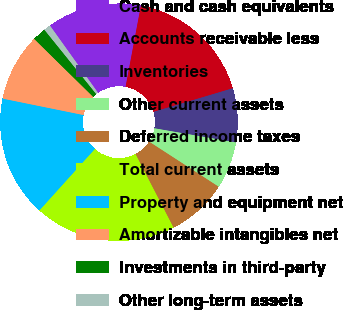<chart> <loc_0><loc_0><loc_500><loc_500><pie_chart><fcel>Cash and cash equivalents<fcel>Accounts receivable less<fcel>Inventories<fcel>Other current assets<fcel>Deferred income taxes<fcel>Total current assets<fcel>Property and equipment net<fcel>Amortizable intangibles net<fcel>Investments in third-party<fcel>Other long-term assets<nl><fcel>12.84%<fcel>17.43%<fcel>7.34%<fcel>6.42%<fcel>8.26%<fcel>19.27%<fcel>16.51%<fcel>9.17%<fcel>1.84%<fcel>0.92%<nl></chart> 